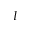<formula> <loc_0><loc_0><loc_500><loc_500>I</formula> 